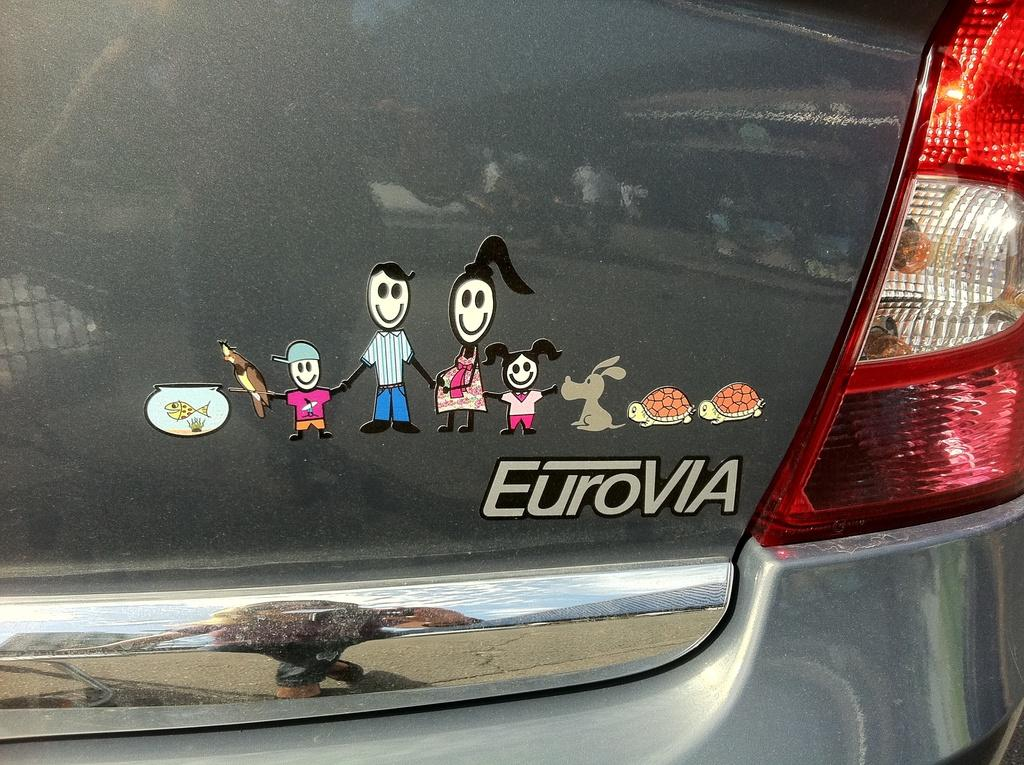What type of decorations are on the car in the image? There are cartoon stickers on the car. What information can be found on the backside of the car? The name of the car is visible on the backside of the car. What safety feature is present on the car? There is a tail lamp on the car. Can you hear a whistle coming from the car in the image? There is no indication of a whistle in the image, so it cannot be heard. Is there a flame visible on the car in the image? There is no flame present in the image. 